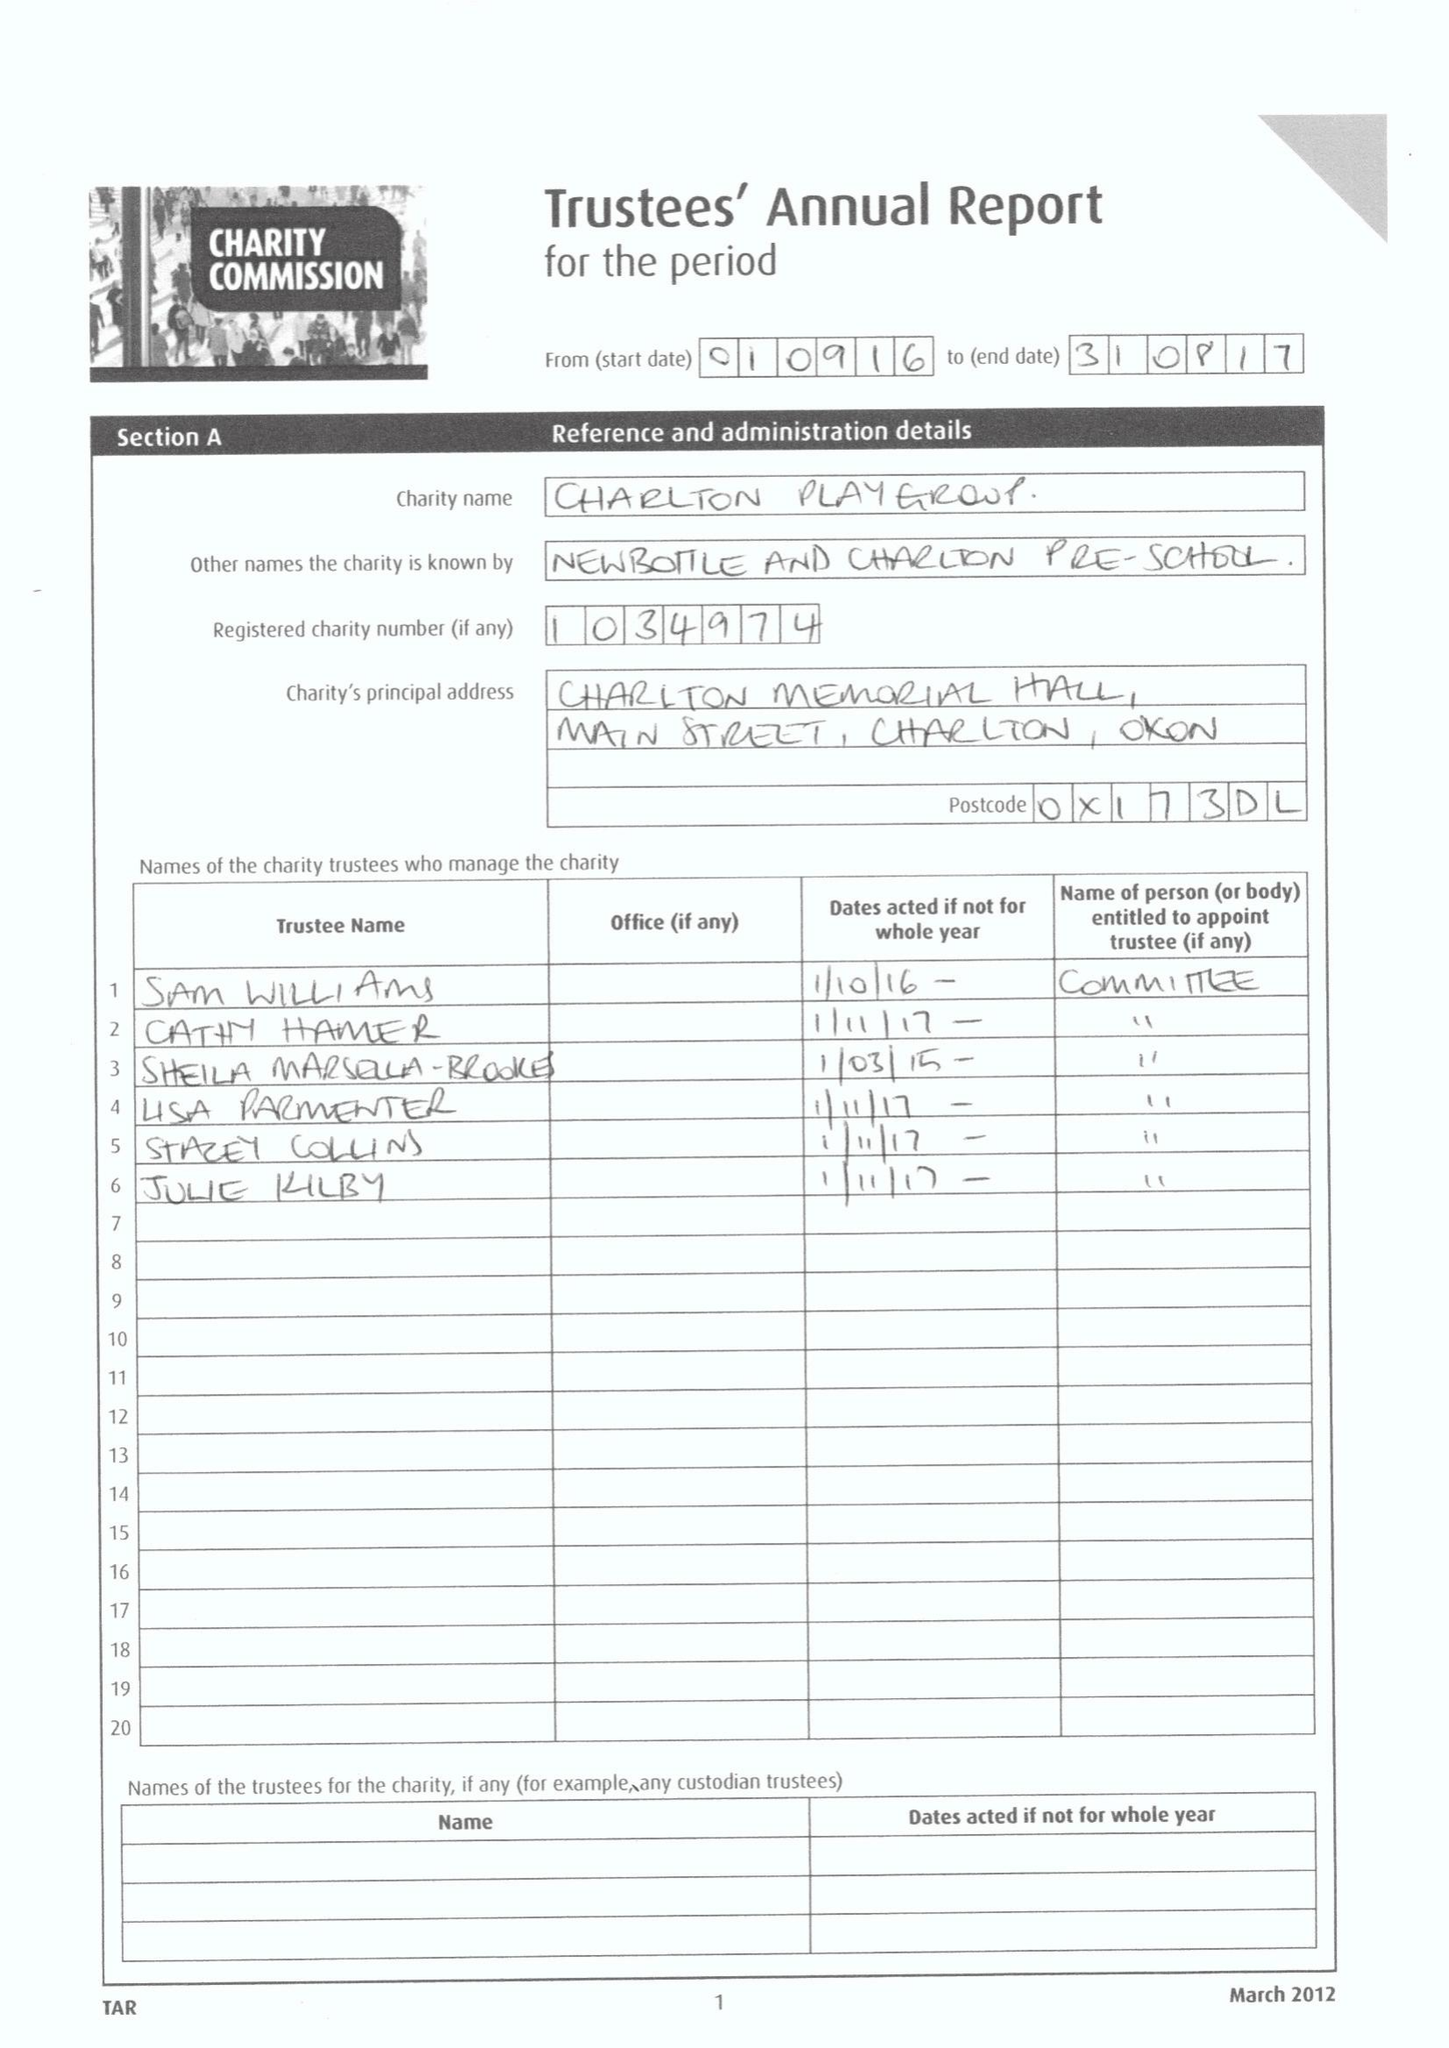What is the value for the charity_name?
Answer the question using a single word or phrase. Charlton Playgroup 